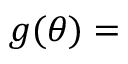Convert formula to latex. <formula><loc_0><loc_0><loc_500><loc_500>g ( \theta ) =</formula> 